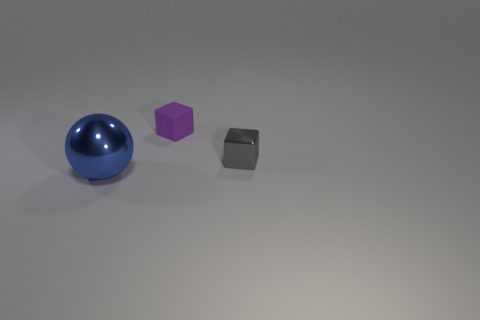Add 1 red matte balls. How many objects exist? 4 Subtract all cubes. How many objects are left? 1 Add 3 small gray objects. How many small gray objects are left? 4 Add 2 small cubes. How many small cubes exist? 4 Subtract 0 green blocks. How many objects are left? 3 Subtract all blue things. Subtract all tiny matte cubes. How many objects are left? 1 